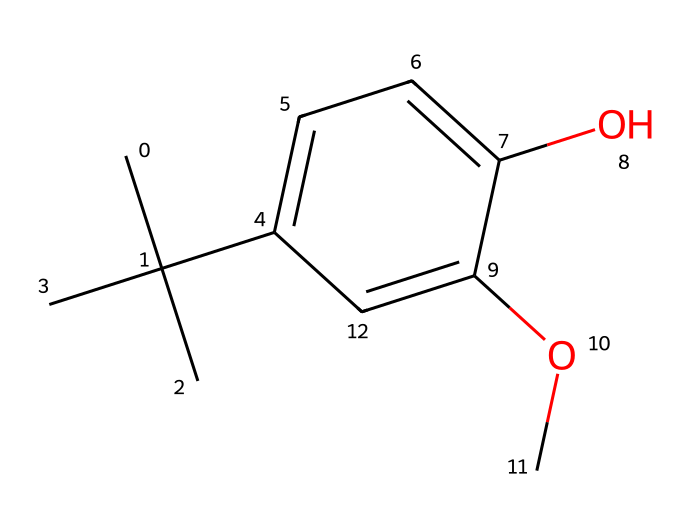What is the molecular formula of butylated hydroxyanisole (BHA)? To find the molecular formula, we can count the number of each type of atom in the SMILES representation. In this case, the atoms include carbon (C), hydrogen (H), and oxygen (O). Upon analysis, we find a total of 11 carbon atoms, 16 hydrogen atoms, and 2 oxygen atoms, leading to the formula C11H16O2.
Answer: C11H16O2 How many aromatic rings are present in BHA? We can identify the presence of a benzene ring by examining the aromatic structure of the chemical. There is one distinct aromatic part in the SMILES representation, which indicates that there is one aromatic ring in the molecule.
Answer: 1 What type of substituent is present at the para position in the aromatic ring? By analyzing the structure derived from the SMILES representation, we see that there is a hydroxyl group (–OH) and a methoxy group (–OCH3) at specific positions of the aromatic ring. The –OH group appears at the para position relative to the methoxy group, indicating that it is a hydroxyl substituent.
Answer: hydroxyl What is the total number of substituents attached to the aromatic ring? Looking at the structure from the SMILES, we note that there are two substituents: the methoxy group and the hydroxyl group attached to the aromatic ring. Additionally, there is a tert-butyl group attached as well, thus totaling three distinct substituents on the ring.
Answer: 3 Is butylated hydroxyanisole (BHA) a natural or synthetic antioxidant? Knowing the definition of antioxidants, we find that BHA is specifically mentioned as a synthetic antioxidant used in various industries. Therefore, it does not occur naturally.
Answer: synthetic What type of antioxidant mechanism does BHA exhibit? The mechanism of BHA works as a chain-breaking antioxidant, which means that it donates a hydrogen atom to free radicals, thus terminating the radical chain reaction. This aspect is a crucial detail when assessing how it functions within various applications.
Answer: chain-breaking 